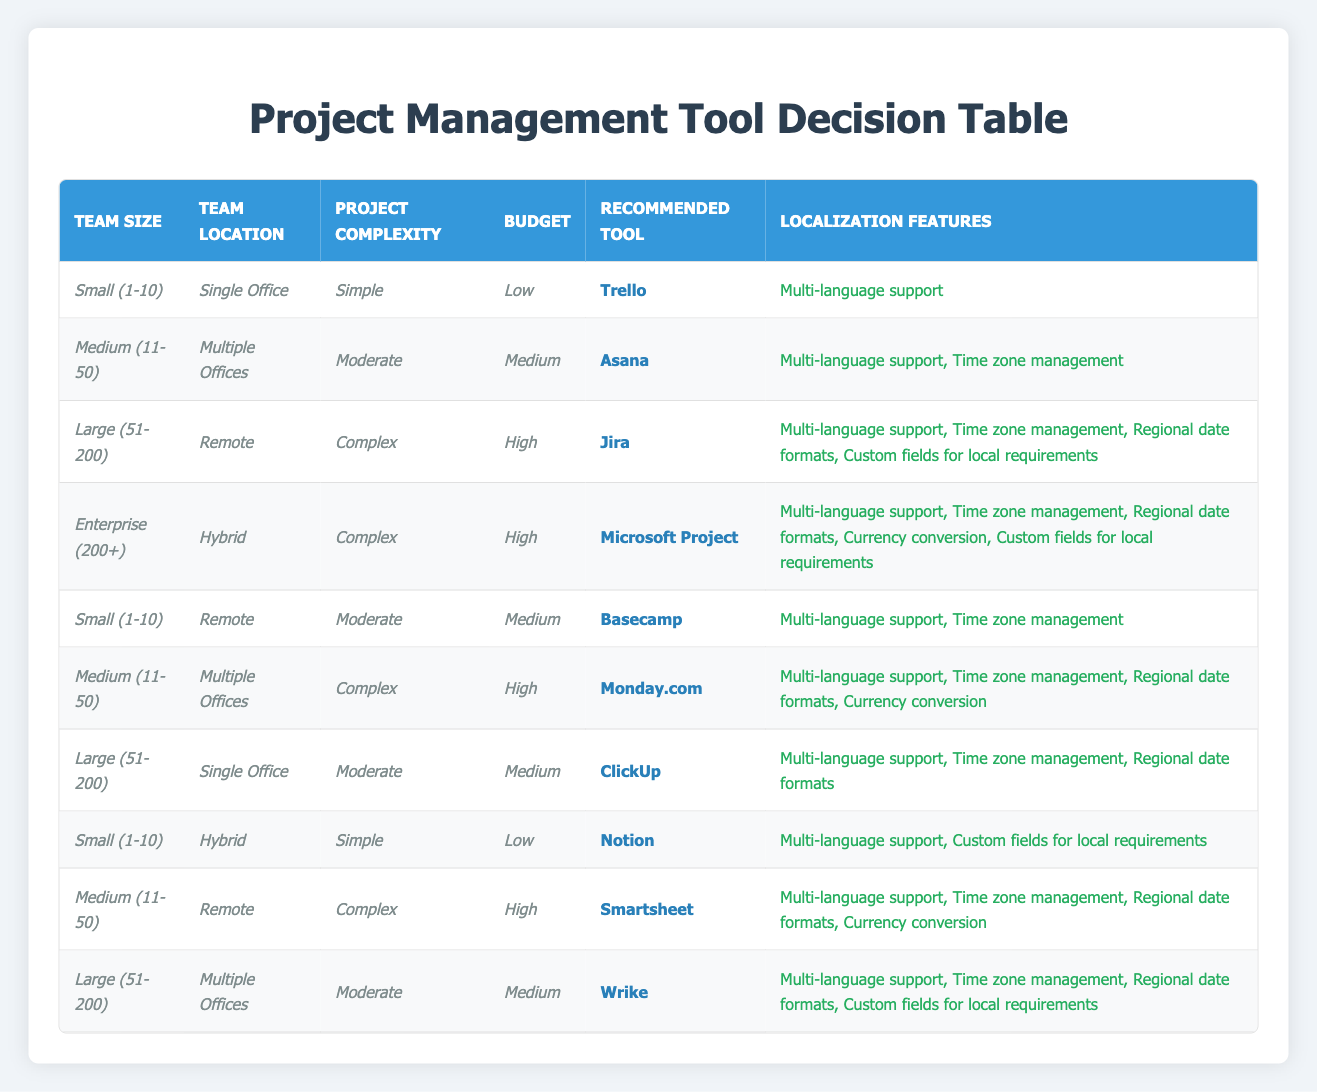What is the recommended project management tool for a medium-sized remote team with a complex project and a high budget? By looking at the table, we check the conditions: "Medium (11-50)" for team size, "Remote" for team location, "Complex" for project complexity, and "High" for budget. The corresponding row shows that the recommended tool is "Smartsheet".
Answer: Smartsheet Which localization features are offered for large teams in single office settings with moderate project complexity and medium budget? We identify the criteria from the table: "Large (51-200)" for team size, "Single Office" for location, "Moderate" for project complexity, and "Medium" for budget. The table indicates that "ClickUp" is recommended, with localization features: "Multi-language support, Time zone management, Regional date formats".
Answer: Multi-language support, Time zone management, Regional date formats Is "Trello" recommended for small teams in hybrid locations with simple projects and low budgets? The table shows that for "Small (1-10)" size, "Hybrid" location, "Simple" project complexity, and "Low" budget, "Notion" is recommended instead. Therefore, the answer is no.
Answer: No How many project management tools are recommended for small teams (1-10) across different locations (Single Office, Remote, Hybrid) with simple projects and low budgets? The table lists "Trello" for a small team in a single office, "Notion" for a small hybrid team, and there are no entries for remote. So, only 2 tools are recommended under these conditions: "Trello" and "Notion".
Answer: 2 If a medium-sized team in multiple offices has a moderate budget, how many localization features will they get from the recommended project management tool? Looking at the table for a "Medium (11-50)" size and "Multiple Offices" location with a "Medium" budget, we can see that the recommended tool is "Asana" with "Multi-language support, Time zone management". This totals 2 localization features.
Answer: 2 Which project management tool is suitable for large, complex, remote teams with high budgets? For "Large (51-200)" teams, "Remote" location, "Complex" projects, and "High" budgets, the table states "Jira" is the recommended tool.
Answer: Jira Are there any localization features available for small (1-10) teams with remote locations and moderate project complexity? The table shows "Basecamp" is recommended for small remote teams with moderate complexity. The localization features provided are "Multi-language support, Time zone management".
Answer: Yes What are the localization features available for enterprise (200+) teams working in a hybrid model with complex projects and high budgets? The table indicates that for "Enterprise (200+)", "Hybrid" location, "Complex" project complexity, and "High" budget, "Microsoft Project" is the suitable tool, offering "Multi-language support, Time zone management, Regional date formats, Currency conversion, Custom fields for local requirements".
Answer: Multi-language support, Time zone management, Regional date formats, Currency conversion, Custom fields for local requirements 